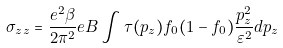Convert formula to latex. <formula><loc_0><loc_0><loc_500><loc_500>\sigma _ { z z } = \frac { e ^ { 2 } \beta } { 2 \pi ^ { 2 } } e B \int \tau ( p _ { z } ) f _ { 0 } ( 1 - f _ { 0 } ) \frac { p _ { z } ^ { 2 } } { \varepsilon ^ { 2 } } d p _ { z }</formula> 